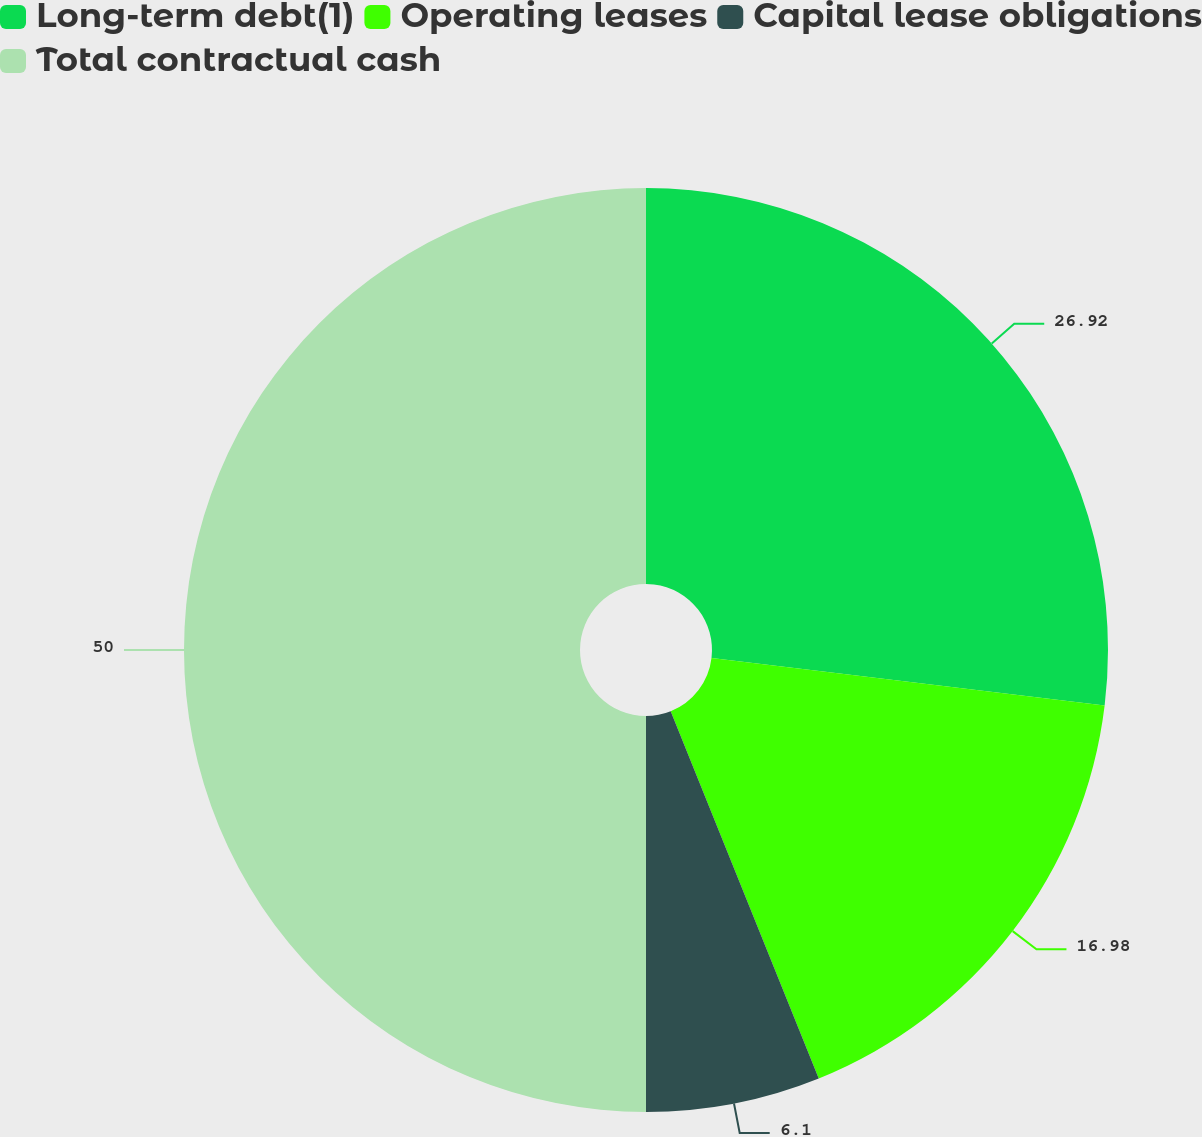Convert chart to OTSL. <chart><loc_0><loc_0><loc_500><loc_500><pie_chart><fcel>Long-term debt(1)<fcel>Operating leases<fcel>Capital lease obligations<fcel>Total contractual cash<nl><fcel>26.92%<fcel>16.98%<fcel>6.1%<fcel>50.0%<nl></chart> 